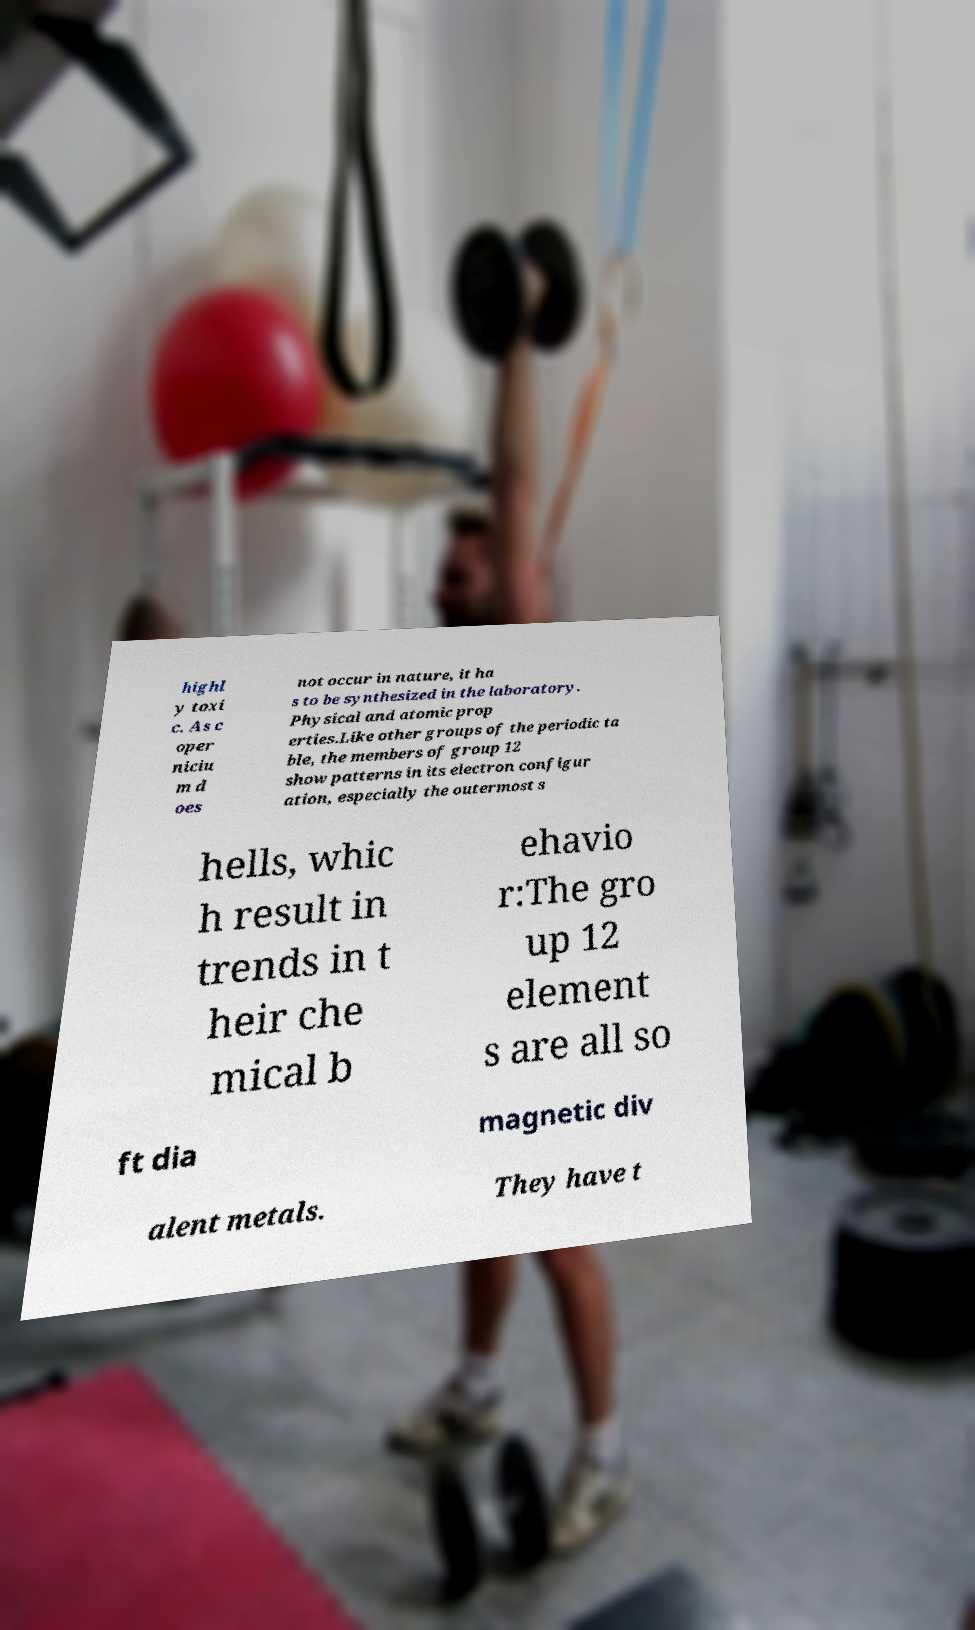What messages or text are displayed in this image? I need them in a readable, typed format. highl y toxi c. As c oper niciu m d oes not occur in nature, it ha s to be synthesized in the laboratory. Physical and atomic prop erties.Like other groups of the periodic ta ble, the members of group 12 show patterns in its electron configur ation, especially the outermost s hells, whic h result in trends in t heir che mical b ehavio r:The gro up 12 element s are all so ft dia magnetic div alent metals. They have t 